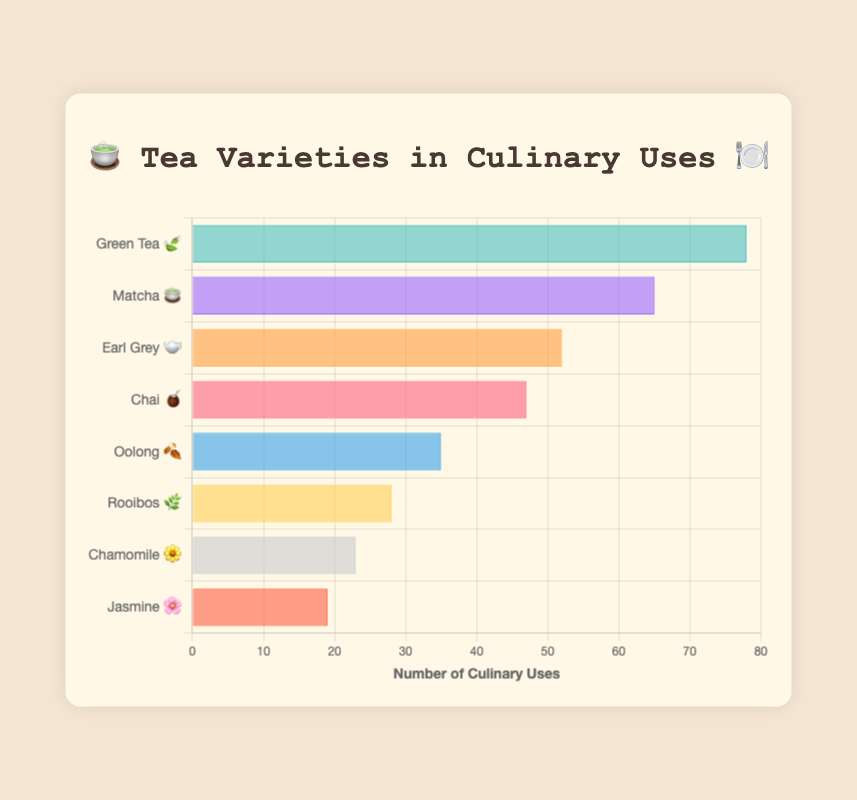What is the most popular tea variety used in cooking? The highest bar in the chart represents Green Tea 🍃 with 78 culinary uses, making it the most popular.
Answer: Green Tea Which tea variety has fewer culinary uses, Matcha 🍵 or Earl Grey 🫖? Matcha has 65 culinary uses, while Earl Grey has 52. Since 52 is less than 65, Earl Grey has fewer culinary uses.
Answer: Earl Grey How many culinary uses does Chamomile 🌼 have? By looking at the Chamomile 🌼 bar on the chart, it indicates 23 culinary uses.
Answer: 23 What is the total number of culinary uses for Green Tea 🍃 and Matcha 🍵 combined? Green Tea has 78 culinary uses and Matcha has 65. Adding them together, 78 + 65 = 143.
Answer: 143 Which tea variety is used more in cooking, Oolong 🍂 or Jasmine 🌸? Oolong has 35 culinary uses while Jasmine has 19. Since 35 is greater than 19, Oolong is used more.
Answer: Oolong What's the difference in culinary uses between Chai 🧉 and Rooibos 🌿? Chai has 47 culinary uses and Rooibos has 28. Finding the difference, 47 - 28 = 19.
Answer: 19 If you ranked the tea varieties by their culinary uses, which position would Chai 🧉 hold? Starting from Green Tea (1st), Matcha (2nd), Earl Grey (3rd), and Chai (4th), Chai holds the 4th position.
Answer: 4th What is the average number of culinary uses for all tea varieties listed? Summing all the culinary uses: 78 + 65 + 52 + 47 + 35 + 28 + 23 + 19 = 347. There are 8 tea varieties, so the average is 347/8 = 43.375.
Answer: 43.375 How many types of tea varieties have culinary uses greater than 50? Green Tea, Matcha, and Earl Grey each have culinary uses greater than 50, totaling 3 types.
Answer: 3 